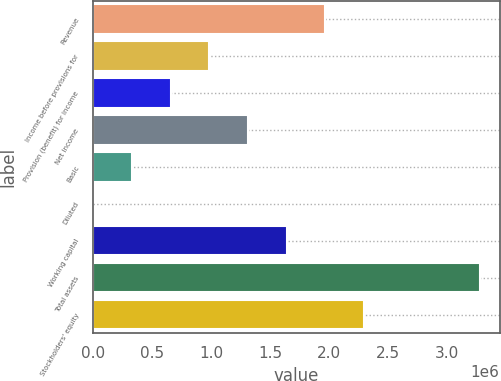Convert chart to OTSL. <chart><loc_0><loc_0><loc_500><loc_500><bar_chart><fcel>Revenue<fcel>Income before provisions for<fcel>Provision (benefit) for income<fcel>Net income<fcel>Basic<fcel>Diluted<fcel>Working capital<fcel>Total assets<fcel>Stockholders' equity<nl><fcel>1.97193e+06<fcel>985963<fcel>657309<fcel>1.31462e+06<fcel>328656<fcel>1.56<fcel>1.64327e+06<fcel>3.28654e+06<fcel>2.30058e+06<nl></chart> 